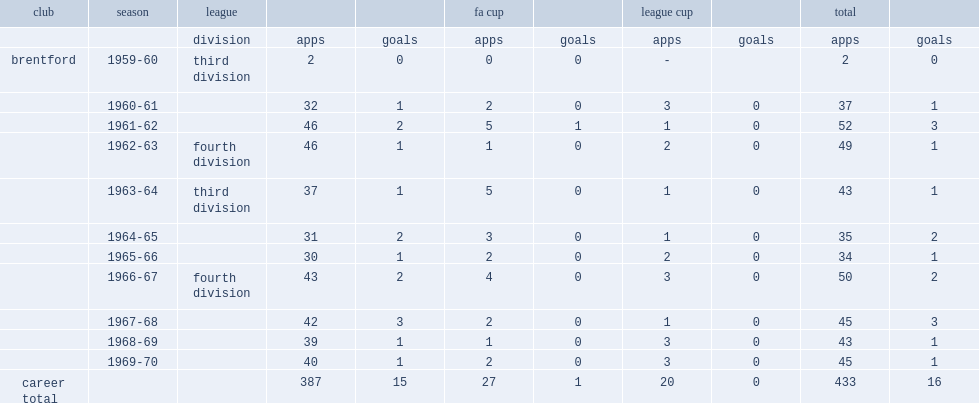How many appearances did tommy higginson make? 433.0. 